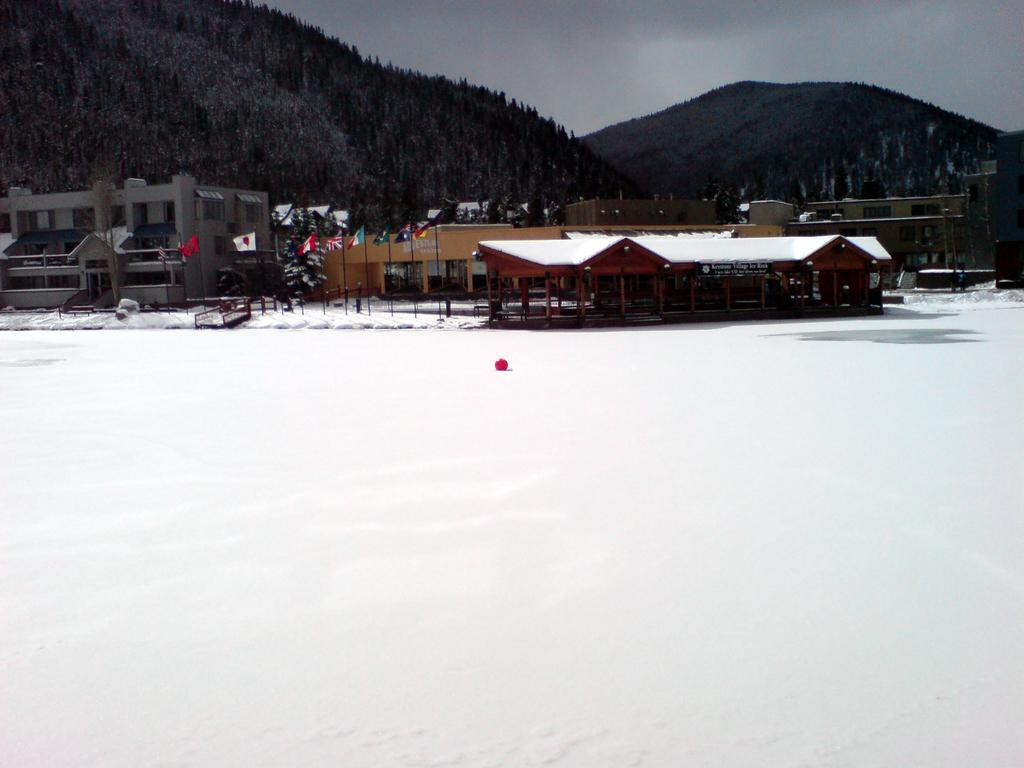What is the predominant weather condition in the image? There is snow in the image, indicating a cold and wintry condition. What type of structures can be seen in the image? There are houses in the image. What other objects are present in the image besides houses? There are flags in the image. What can be seen in the background of the image? There are hills covered with trees and the sky visible in the background of the image. What type of sheet is draped over the chair in the image? There is no sheet or chair present in the image; it features snow, houses, flags, hills, and trees. 